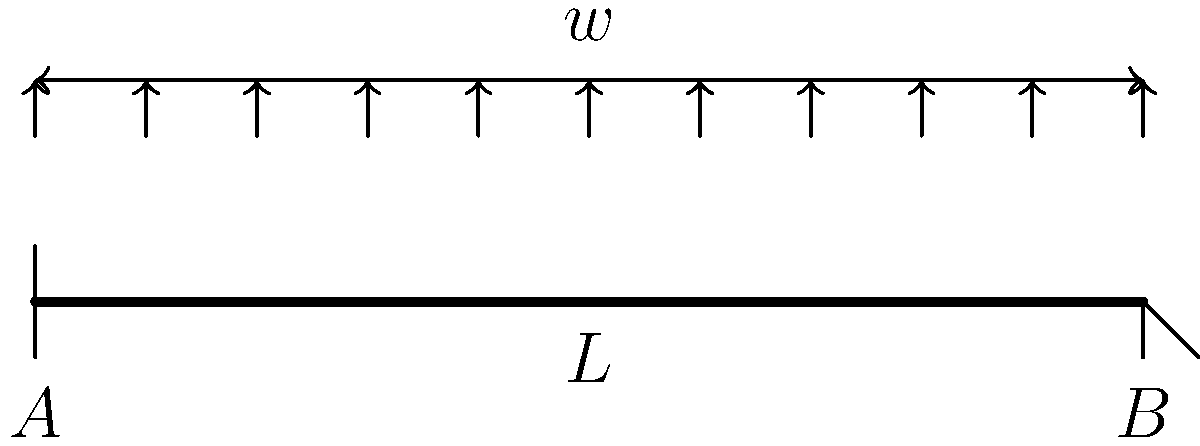As a health department director evaluating council members' performance in public health initiatives, you're assessing a proposal for a new medical facility. The structural integrity of the building is crucial for patient safety. Consider a simply supported beam of length $L$ subjected to a uniformly distributed load $w$ per unit length. Determine the maximum bending stress $\sigma_{max}$ in the beam if its cross-section is rectangular with width $b$ and height $h$. To determine the maximum bending stress, we'll follow these steps:

1) First, calculate the maximum bending moment $M_{max}$:
   For a simply supported beam with uniformly distributed load:
   $$M_{max} = \frac{wL^2}{8}$$

2) Calculate the moment of inertia $I$ for a rectangular cross-section:
   $$I = \frac{bh^3}{12}$$

3) Determine the distance $y$ from the neutral axis to the outermost fiber:
   $$y = \frac{h}{2}$$

4) Apply the flexure formula to calculate the maximum bending stress:
   $$\sigma_{max} = \frac{M_{max}y}{I}$$

5) Substitute the expressions for $M_{max}$, $I$, and $y$:
   $$\sigma_{max} = \frac{(\frac{wL^2}{8})(\frac{h}{2})}{(\frac{bh^3}{12})}$$

6) Simplify:
   $$\sigma_{max} = \frac{3wL^2}{4bh^2}$$

This formula gives the maximum bending stress in the beam, which occurs at the mid-span on the top and bottom surfaces.
Answer: $\sigma_{max} = \frac{3wL^2}{4bh^2}$ 